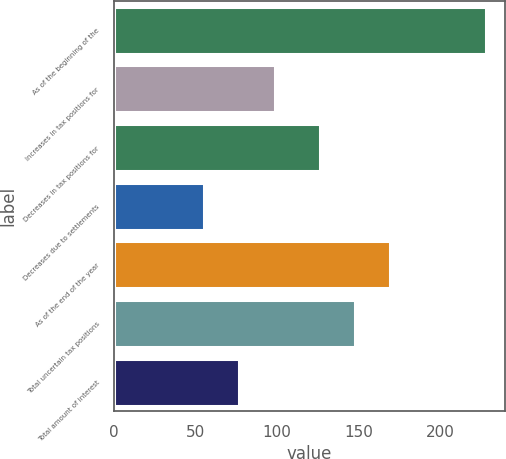<chart> <loc_0><loc_0><loc_500><loc_500><bar_chart><fcel>As of the beginning of the<fcel>Increases in tax positions for<fcel>Decreases in tax positions for<fcel>Decreases due to settlements<fcel>As of the end of the year<fcel>Total uncertain tax positions<fcel>Total amount of interest<nl><fcel>228<fcel>98.4<fcel>126<fcel>55.2<fcel>169.2<fcel>147.6<fcel>76.8<nl></chart> 